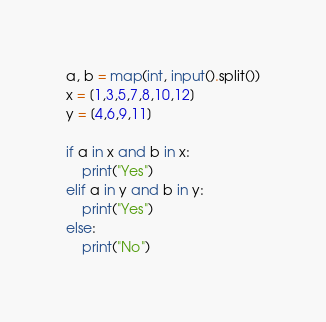<code> <loc_0><loc_0><loc_500><loc_500><_Python_>a, b = map(int, input().split())
x = [1,3,5,7,8,10,12]
y = [4,6,9,11]

if a in x and b in x:
    print("Yes")
elif a in y and b in y:
    print("Yes")
else:
    print("No")</code> 